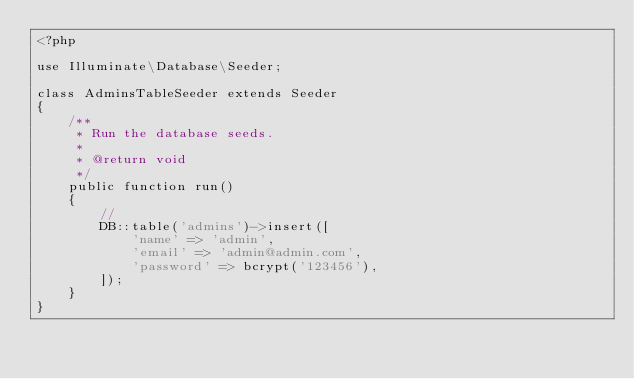<code> <loc_0><loc_0><loc_500><loc_500><_PHP_><?php

use Illuminate\Database\Seeder;

class AdminsTableSeeder extends Seeder
{
    /**
     * Run the database seeds.
     *
     * @return void
     */
    public function run()
    {
        //
        DB::table('admins')->insert([
            'name' => 'admin',
            'email' => 'admin@admin.com',
            'password' => bcrypt('123456'),
        ]);
    }
}
</code> 